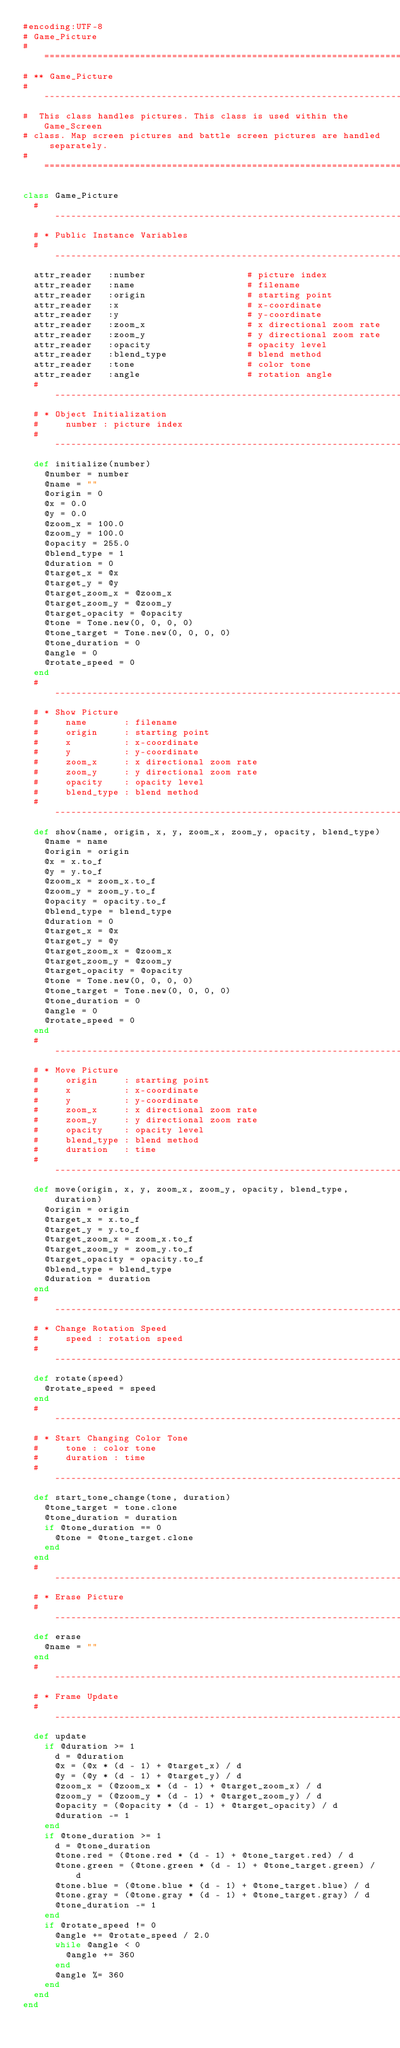Convert code to text. <code><loc_0><loc_0><loc_500><loc_500><_Ruby_>#encoding:UTF-8
# Game_Picture
#==============================================================================
# ** Game_Picture
#------------------------------------------------------------------------------
#  This class handles pictures. This class is used within the Game_Screen
# class. Map screen pictures and battle screen pictures are handled separately.
#==============================================================================

class Game_Picture
  #--------------------------------------------------------------------------
  # * Public Instance Variables
  #--------------------------------------------------------------------------
  attr_reader   :number                   # picture index
  attr_reader   :name                     # filename
  attr_reader   :origin                   # starting point
  attr_reader   :x                        # x-coordinate
  attr_reader   :y                        # y-coordinate
  attr_reader   :zoom_x                   # x directional zoom rate
  attr_reader   :zoom_y                   # y directional zoom rate
  attr_reader   :opacity                  # opacity level
  attr_reader   :blend_type               # blend method
  attr_reader   :tone                     # color tone
  attr_reader   :angle                    # rotation angle
  #--------------------------------------------------------------------------
  # * Object Initialization
  #     number : picture index
  #--------------------------------------------------------------------------
  def initialize(number)
    @number = number
    @name = ""
    @origin = 0
    @x = 0.0
    @y = 0.0
    @zoom_x = 100.0
    @zoom_y = 100.0
    @opacity = 255.0
    @blend_type = 1
    @duration = 0
    @target_x = @x
    @target_y = @y
    @target_zoom_x = @zoom_x
    @target_zoom_y = @zoom_y
    @target_opacity = @opacity
    @tone = Tone.new(0, 0, 0, 0)
    @tone_target = Tone.new(0, 0, 0, 0)
    @tone_duration = 0
    @angle = 0
    @rotate_speed = 0
  end
  #--------------------------------------------------------------------------
  # * Show Picture
  #     name       : filename
  #     origin     : starting point
  #     x          : x-coordinate
  #     y          : y-coordinate
  #     zoom_x     : x directional zoom rate
  #     zoom_y     : y directional zoom rate
  #     opacity    : opacity level
  #     blend_type : blend method
  #--------------------------------------------------------------------------
  def show(name, origin, x, y, zoom_x, zoom_y, opacity, blend_type)
    @name = name
    @origin = origin
    @x = x.to_f
    @y = y.to_f
    @zoom_x = zoom_x.to_f
    @zoom_y = zoom_y.to_f
    @opacity = opacity.to_f
    @blend_type = blend_type
    @duration = 0
    @target_x = @x
    @target_y = @y
    @target_zoom_x = @zoom_x
    @target_zoom_y = @zoom_y
    @target_opacity = @opacity
    @tone = Tone.new(0, 0, 0, 0)
    @tone_target = Tone.new(0, 0, 0, 0)
    @tone_duration = 0
    @angle = 0
    @rotate_speed = 0
  end
  #--------------------------------------------------------------------------
  # * Move Picture
  #     origin     : starting point
  #     x          : x-coordinate
  #     y          : y-coordinate
  #     zoom_x     : x directional zoom rate
  #     zoom_y     : y directional zoom rate
  #     opacity    : opacity level
  #     blend_type : blend method
  #     duration   : time
  #--------------------------------------------------------------------------
  def move(origin, x, y, zoom_x, zoom_y, opacity, blend_type, duration)
    @origin = origin
    @target_x = x.to_f
    @target_y = y.to_f
    @target_zoom_x = zoom_x.to_f
    @target_zoom_y = zoom_y.to_f
    @target_opacity = opacity.to_f
    @blend_type = blend_type
    @duration = duration
  end
  #--------------------------------------------------------------------------
  # * Change Rotation Speed
  #     speed : rotation speed
  #--------------------------------------------------------------------------
  def rotate(speed)
    @rotate_speed = speed
  end
  #--------------------------------------------------------------------------
  # * Start Changing Color Tone
  #     tone : color tone
  #     duration : time
  #--------------------------------------------------------------------------
  def start_tone_change(tone, duration)
    @tone_target = tone.clone
    @tone_duration = duration
    if @tone_duration == 0
      @tone = @tone_target.clone
    end
  end
  #--------------------------------------------------------------------------
  # * Erase Picture
  #--------------------------------------------------------------------------
  def erase
    @name = ""
  end
  #--------------------------------------------------------------------------
  # * Frame Update
  #--------------------------------------------------------------------------
  def update
    if @duration >= 1
      d = @duration
      @x = (@x * (d - 1) + @target_x) / d
      @y = (@y * (d - 1) + @target_y) / d
      @zoom_x = (@zoom_x * (d - 1) + @target_zoom_x) / d
      @zoom_y = (@zoom_y * (d - 1) + @target_zoom_y) / d
      @opacity = (@opacity * (d - 1) + @target_opacity) / d
      @duration -= 1
    end
    if @tone_duration >= 1
      d = @tone_duration
      @tone.red = (@tone.red * (d - 1) + @tone_target.red) / d
      @tone.green = (@tone.green * (d - 1) + @tone_target.green) / d
      @tone.blue = (@tone.blue * (d - 1) + @tone_target.blue) / d
      @tone.gray = (@tone.gray * (d - 1) + @tone_target.gray) / d
      @tone_duration -= 1
    end
    if @rotate_speed != 0
      @angle += @rotate_speed / 2.0
      while @angle < 0
        @angle += 360
      end
      @angle %= 360
    end
  end
end
</code> 